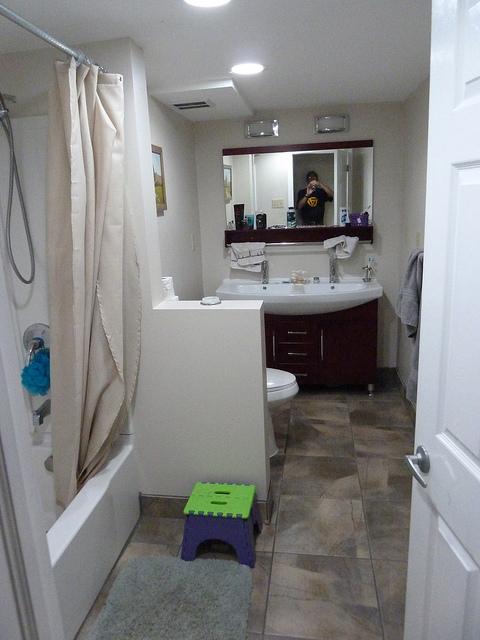What room is this?
Be succinct. Bathroom. What color is the little stool?
Concise answer only. Purple and green. What color is the stool?
Be succinct. Blue and green. 